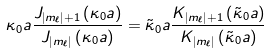<formula> <loc_0><loc_0><loc_500><loc_500>\kappa _ { 0 } a \frac { J _ { \left | m _ { \ell } \right | + 1 } \left ( \kappa _ { 0 } a \right ) } { J _ { \left | m _ { \ell } \right | } \left ( \kappa _ { 0 } a \right ) } = \tilde { \kappa } _ { 0 } a \frac { K _ { \left | m _ { \ell } \right | + 1 } \left ( \tilde { \kappa } _ { 0 } a \right ) } { K _ { \left | m _ { \ell } \right | } \left ( \tilde { \kappa } _ { 0 } a \right ) }</formula> 